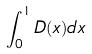Convert formula to latex. <formula><loc_0><loc_0><loc_500><loc_500>\int _ { 0 } ^ { 1 } D ( x ) d x</formula> 